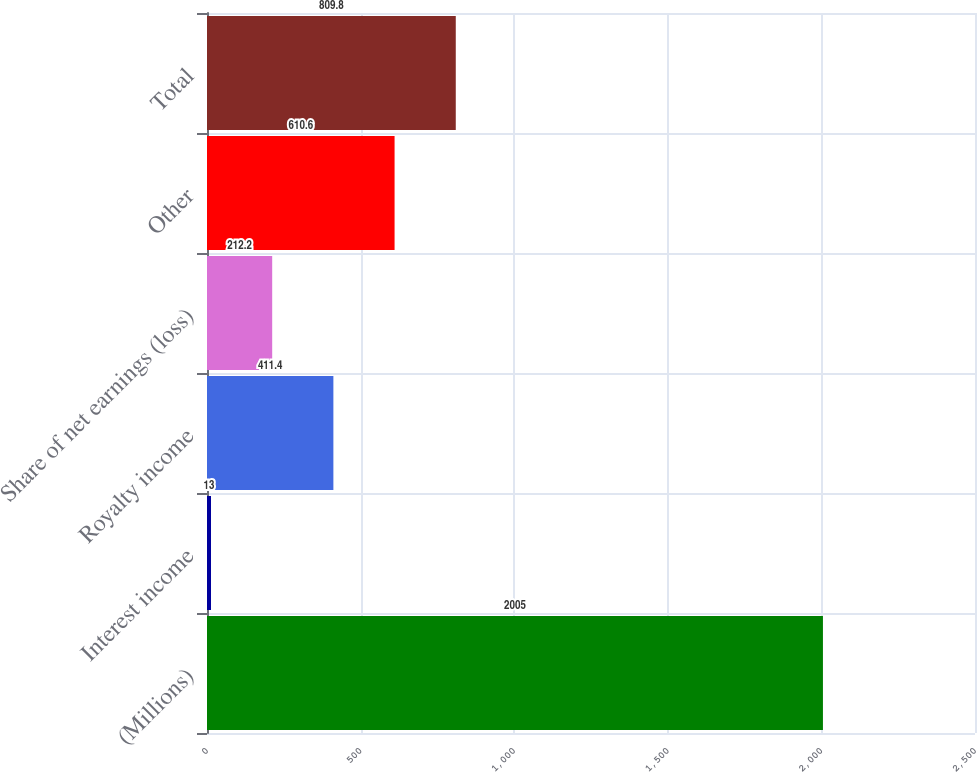<chart> <loc_0><loc_0><loc_500><loc_500><bar_chart><fcel>(Millions)<fcel>Interest income<fcel>Royalty income<fcel>Share of net earnings (loss)<fcel>Other<fcel>Total<nl><fcel>2005<fcel>13<fcel>411.4<fcel>212.2<fcel>610.6<fcel>809.8<nl></chart> 